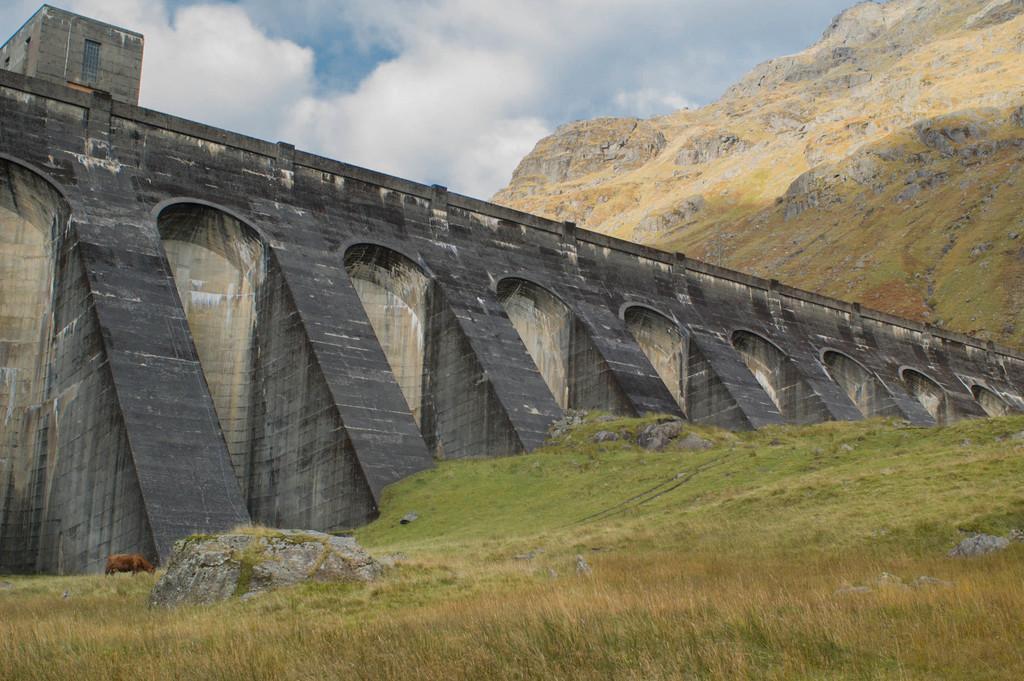How would you summarize this image in a sentence or two? There is a grassy land at the bottom of this image. We can see a bridge in the middle of this image. There is a mountain on the right side of this image and the cloudy sky is in the background. 